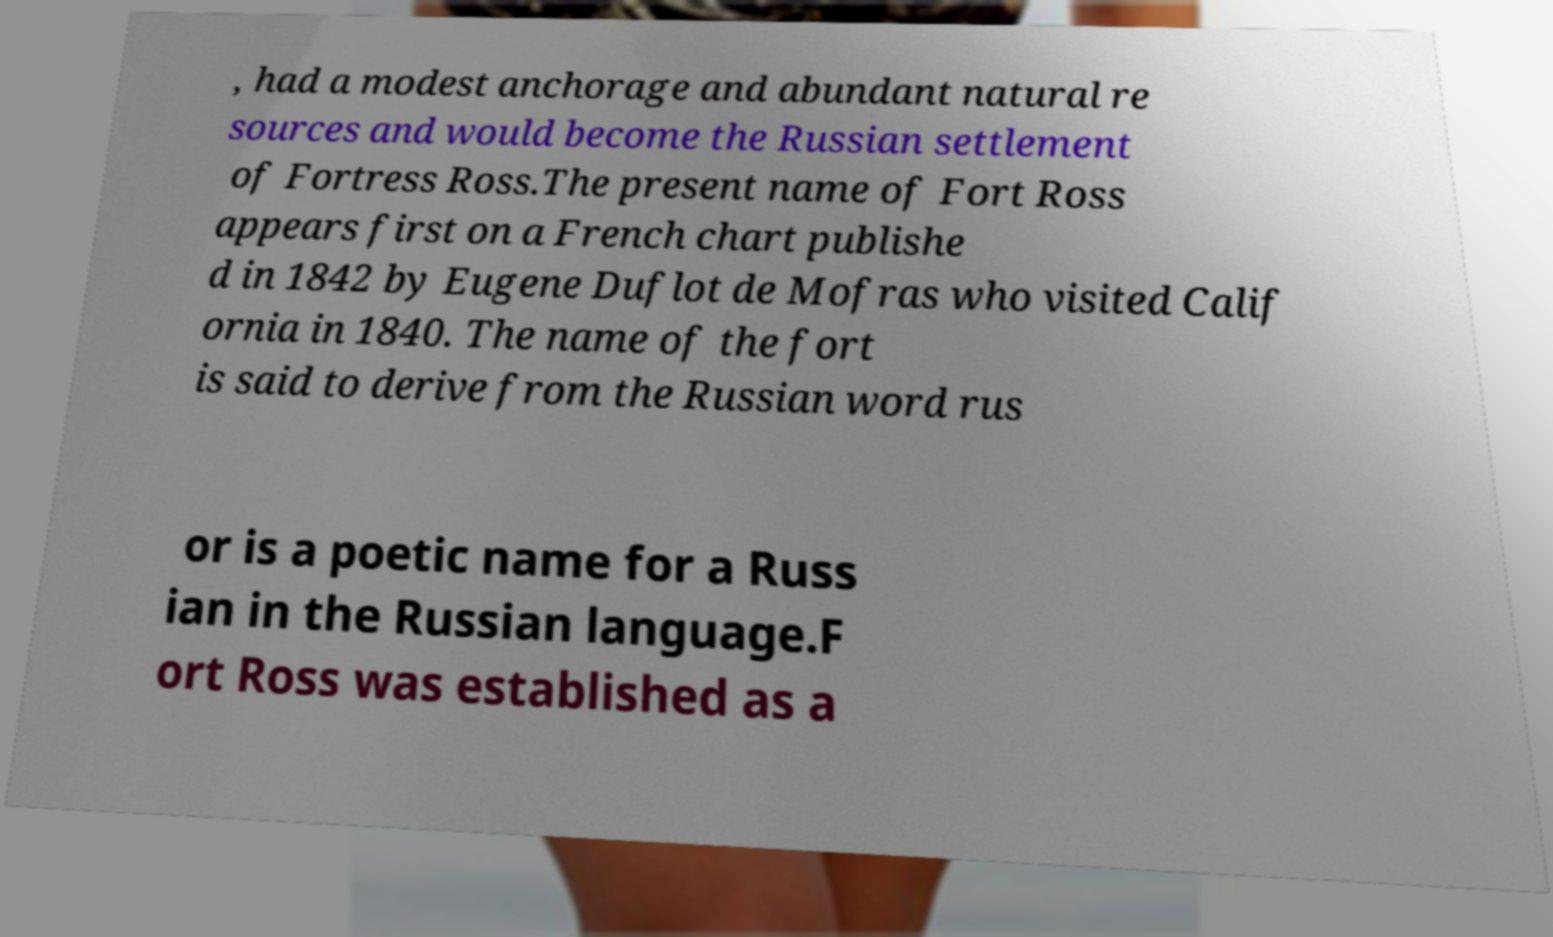I need the written content from this picture converted into text. Can you do that? , had a modest anchorage and abundant natural re sources and would become the Russian settlement of Fortress Ross.The present name of Fort Ross appears first on a French chart publishe d in 1842 by Eugene Duflot de Mofras who visited Calif ornia in 1840. The name of the fort is said to derive from the Russian word rus or is a poetic name for a Russ ian in the Russian language.F ort Ross was established as a 